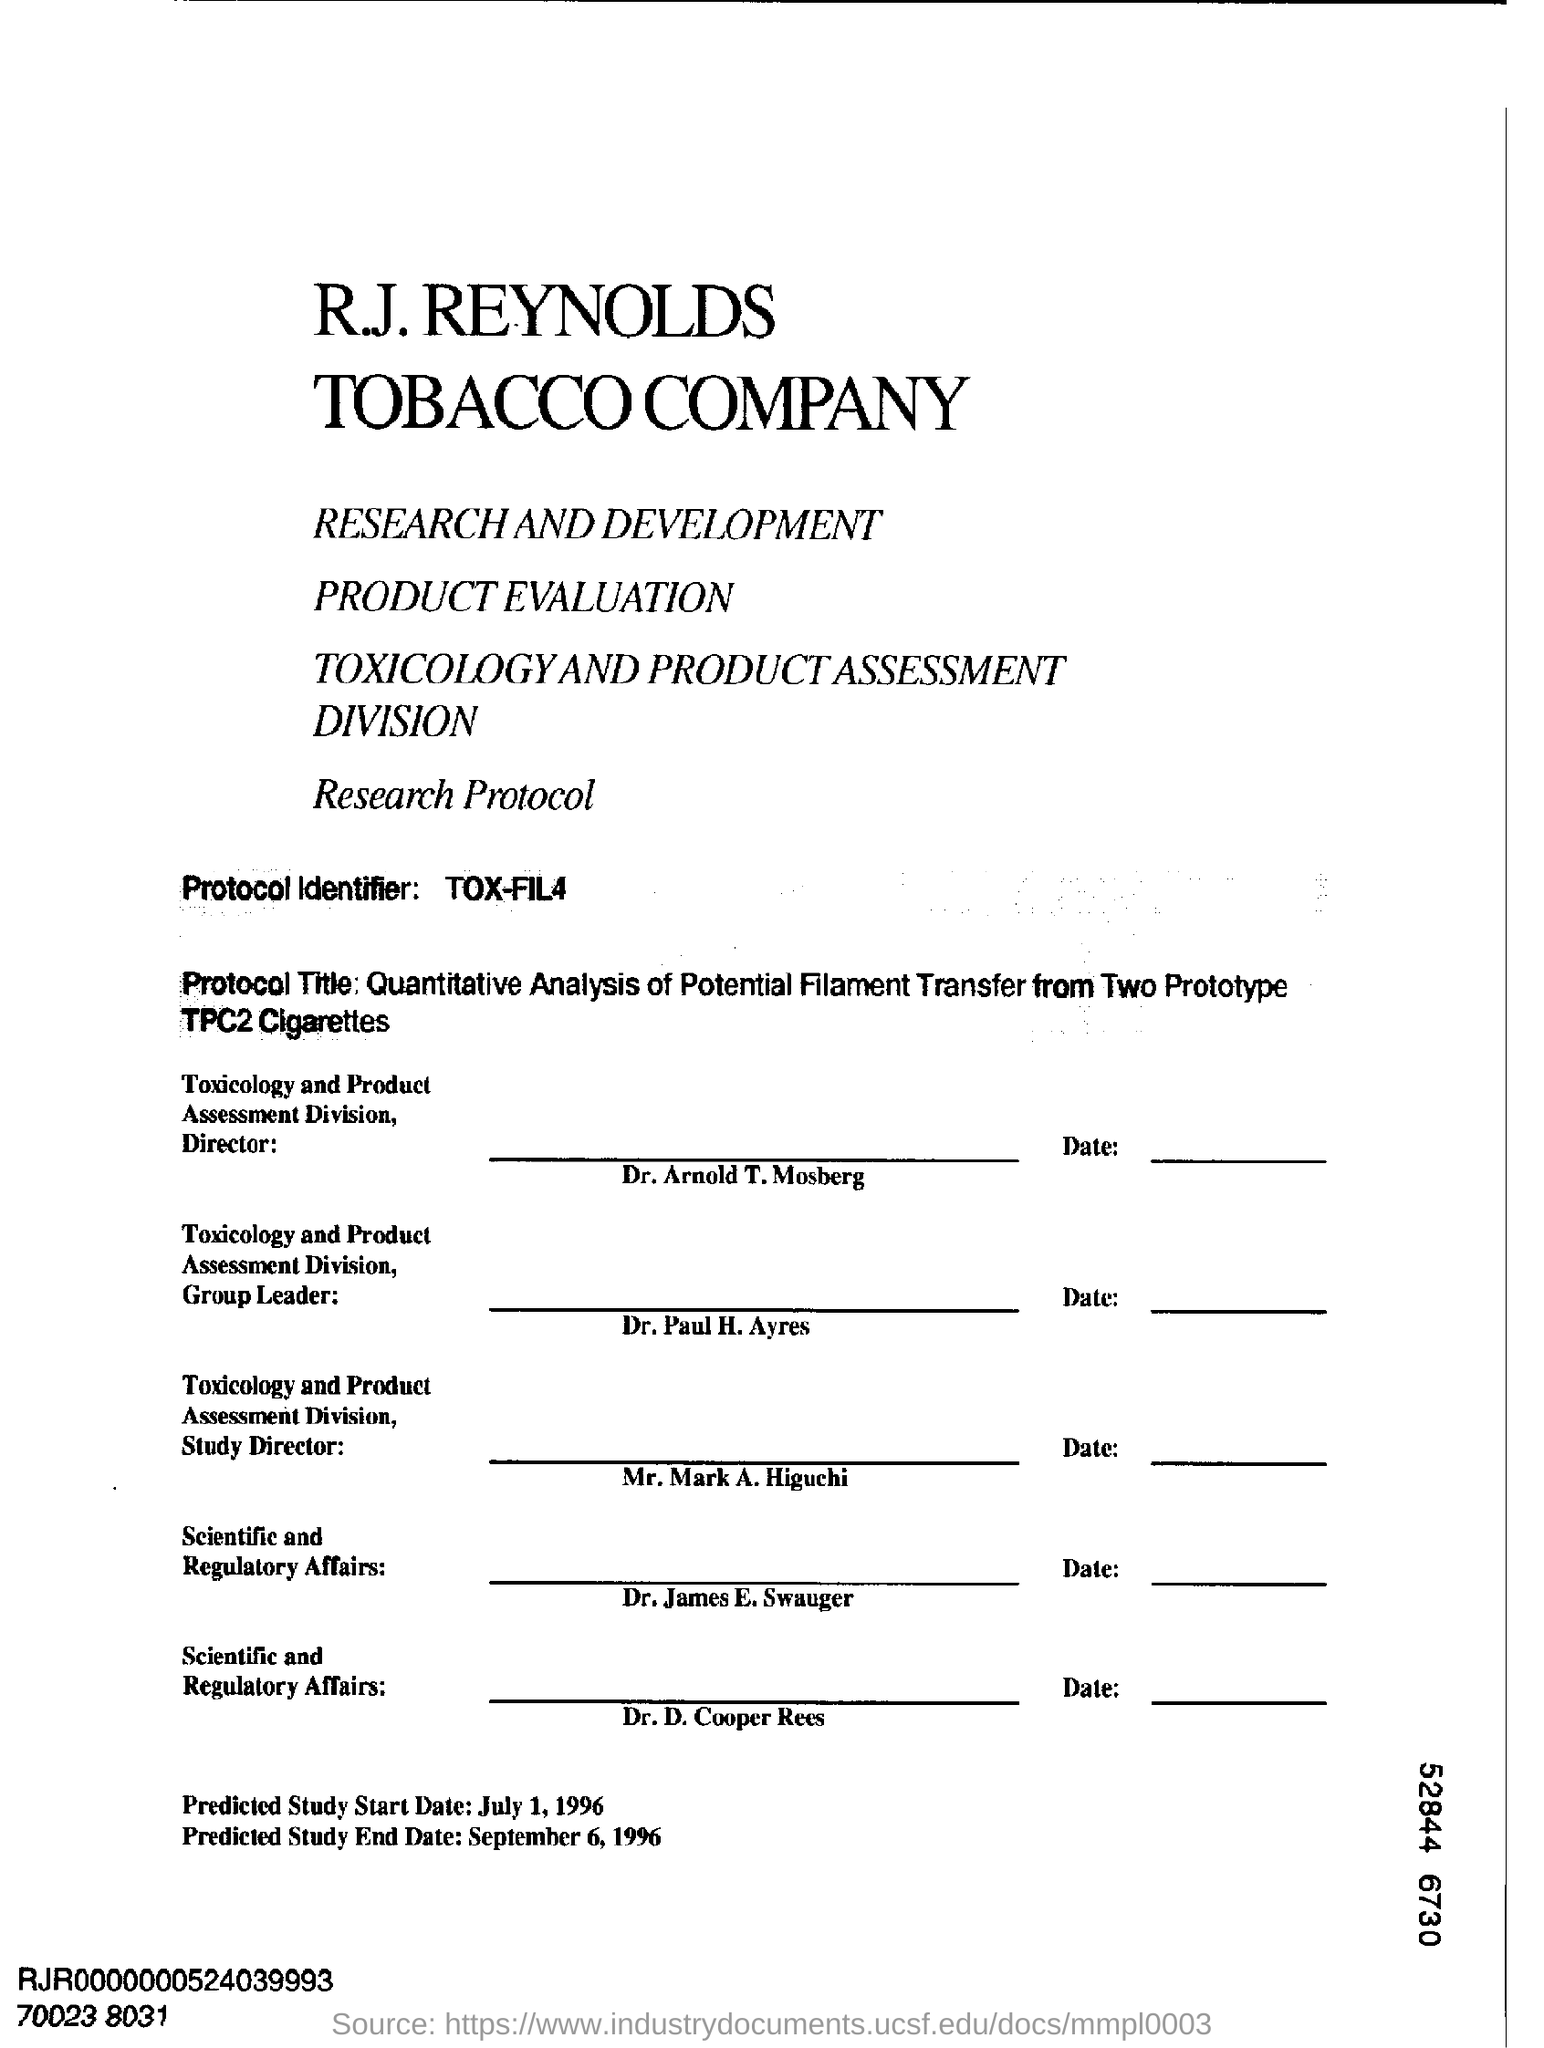What is Protocol Identifier?
Offer a very short reply. TOX-FIL4. Who is the Toxicology and Product assessment division director?
Give a very brief answer. Dr. Arnold T. Mosberg. What is the predicted start date of the study?
Make the answer very short. July 1 , 1996. 